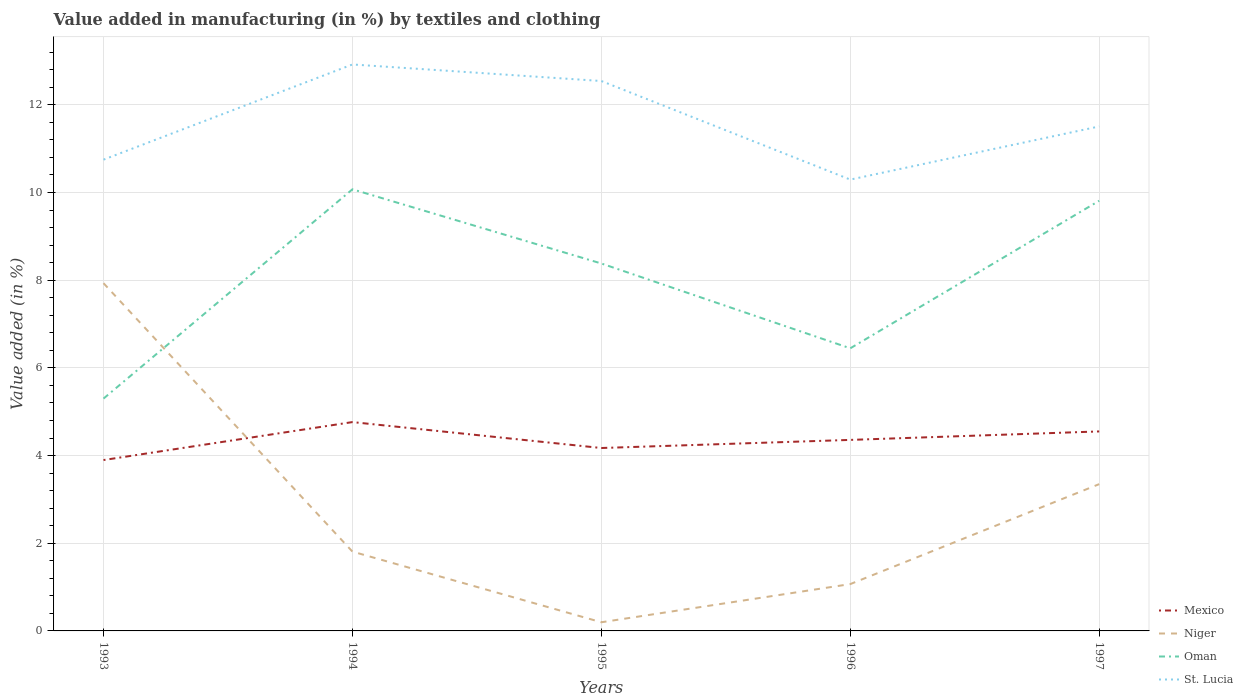Does the line corresponding to Oman intersect with the line corresponding to St. Lucia?
Offer a very short reply. No. Is the number of lines equal to the number of legend labels?
Provide a succinct answer. Yes. Across all years, what is the maximum percentage of value added in manufacturing by textiles and clothing in Mexico?
Provide a short and direct response. 3.9. What is the total percentage of value added in manufacturing by textiles and clothing in Oman in the graph?
Give a very brief answer. 0.26. What is the difference between the highest and the second highest percentage of value added in manufacturing by textiles and clothing in Niger?
Your answer should be very brief. 7.73. What is the difference between the highest and the lowest percentage of value added in manufacturing by textiles and clothing in Mexico?
Give a very brief answer. 3. How many lines are there?
Offer a very short reply. 4. What is the difference between two consecutive major ticks on the Y-axis?
Provide a succinct answer. 2. Does the graph contain grids?
Your response must be concise. Yes. How many legend labels are there?
Your response must be concise. 4. How are the legend labels stacked?
Your answer should be very brief. Vertical. What is the title of the graph?
Give a very brief answer. Value added in manufacturing (in %) by textiles and clothing. Does "Mali" appear as one of the legend labels in the graph?
Make the answer very short. No. What is the label or title of the Y-axis?
Ensure brevity in your answer.  Value added (in %). What is the Value added (in %) in Mexico in 1993?
Offer a very short reply. 3.9. What is the Value added (in %) of Niger in 1993?
Offer a very short reply. 7.93. What is the Value added (in %) of Oman in 1993?
Your answer should be compact. 5.3. What is the Value added (in %) in St. Lucia in 1993?
Give a very brief answer. 10.75. What is the Value added (in %) in Mexico in 1994?
Your answer should be compact. 4.76. What is the Value added (in %) in Niger in 1994?
Offer a very short reply. 1.81. What is the Value added (in %) in Oman in 1994?
Provide a succinct answer. 10.07. What is the Value added (in %) of St. Lucia in 1994?
Offer a terse response. 12.92. What is the Value added (in %) of Mexico in 1995?
Your answer should be very brief. 4.17. What is the Value added (in %) of Niger in 1995?
Keep it short and to the point. 0.2. What is the Value added (in %) in Oman in 1995?
Ensure brevity in your answer.  8.38. What is the Value added (in %) in St. Lucia in 1995?
Provide a succinct answer. 12.54. What is the Value added (in %) in Mexico in 1996?
Give a very brief answer. 4.36. What is the Value added (in %) of Niger in 1996?
Offer a terse response. 1.07. What is the Value added (in %) in Oman in 1996?
Your response must be concise. 6.45. What is the Value added (in %) of St. Lucia in 1996?
Provide a succinct answer. 10.29. What is the Value added (in %) of Mexico in 1997?
Your answer should be very brief. 4.55. What is the Value added (in %) in Niger in 1997?
Ensure brevity in your answer.  3.35. What is the Value added (in %) of Oman in 1997?
Offer a terse response. 9.81. What is the Value added (in %) of St. Lucia in 1997?
Your response must be concise. 11.51. Across all years, what is the maximum Value added (in %) of Mexico?
Offer a terse response. 4.76. Across all years, what is the maximum Value added (in %) in Niger?
Keep it short and to the point. 7.93. Across all years, what is the maximum Value added (in %) in Oman?
Offer a very short reply. 10.07. Across all years, what is the maximum Value added (in %) of St. Lucia?
Give a very brief answer. 12.92. Across all years, what is the minimum Value added (in %) of Mexico?
Give a very brief answer. 3.9. Across all years, what is the minimum Value added (in %) in Niger?
Offer a very short reply. 0.2. Across all years, what is the minimum Value added (in %) of Oman?
Ensure brevity in your answer.  5.3. Across all years, what is the minimum Value added (in %) in St. Lucia?
Offer a terse response. 10.29. What is the total Value added (in %) of Mexico in the graph?
Your answer should be compact. 21.74. What is the total Value added (in %) of Niger in the graph?
Your response must be concise. 14.35. What is the total Value added (in %) in Oman in the graph?
Provide a short and direct response. 40.01. What is the total Value added (in %) of St. Lucia in the graph?
Keep it short and to the point. 58.01. What is the difference between the Value added (in %) in Mexico in 1993 and that in 1994?
Offer a very short reply. -0.87. What is the difference between the Value added (in %) in Niger in 1993 and that in 1994?
Your answer should be compact. 6.12. What is the difference between the Value added (in %) in Oman in 1993 and that in 1994?
Offer a terse response. -4.77. What is the difference between the Value added (in %) in St. Lucia in 1993 and that in 1994?
Offer a terse response. -2.17. What is the difference between the Value added (in %) of Mexico in 1993 and that in 1995?
Offer a very short reply. -0.27. What is the difference between the Value added (in %) of Niger in 1993 and that in 1995?
Give a very brief answer. 7.73. What is the difference between the Value added (in %) in Oman in 1993 and that in 1995?
Give a very brief answer. -3.08. What is the difference between the Value added (in %) in St. Lucia in 1993 and that in 1995?
Offer a terse response. -1.79. What is the difference between the Value added (in %) in Mexico in 1993 and that in 1996?
Your answer should be compact. -0.46. What is the difference between the Value added (in %) of Niger in 1993 and that in 1996?
Offer a very short reply. 6.86. What is the difference between the Value added (in %) of Oman in 1993 and that in 1996?
Your answer should be compact. -1.15. What is the difference between the Value added (in %) in St. Lucia in 1993 and that in 1996?
Your response must be concise. 0.45. What is the difference between the Value added (in %) of Mexico in 1993 and that in 1997?
Ensure brevity in your answer.  -0.65. What is the difference between the Value added (in %) of Niger in 1993 and that in 1997?
Make the answer very short. 4.58. What is the difference between the Value added (in %) in Oman in 1993 and that in 1997?
Offer a very short reply. -4.51. What is the difference between the Value added (in %) of St. Lucia in 1993 and that in 1997?
Your response must be concise. -0.76. What is the difference between the Value added (in %) in Mexico in 1994 and that in 1995?
Give a very brief answer. 0.59. What is the difference between the Value added (in %) in Niger in 1994 and that in 1995?
Provide a short and direct response. 1.61. What is the difference between the Value added (in %) in Oman in 1994 and that in 1995?
Ensure brevity in your answer.  1.69. What is the difference between the Value added (in %) in St. Lucia in 1994 and that in 1995?
Give a very brief answer. 0.38. What is the difference between the Value added (in %) in Mexico in 1994 and that in 1996?
Give a very brief answer. 0.41. What is the difference between the Value added (in %) in Niger in 1994 and that in 1996?
Offer a terse response. 0.74. What is the difference between the Value added (in %) in Oman in 1994 and that in 1996?
Your answer should be very brief. 3.63. What is the difference between the Value added (in %) in St. Lucia in 1994 and that in 1996?
Offer a terse response. 2.63. What is the difference between the Value added (in %) in Mexico in 1994 and that in 1997?
Your response must be concise. 0.21. What is the difference between the Value added (in %) in Niger in 1994 and that in 1997?
Offer a very short reply. -1.54. What is the difference between the Value added (in %) of Oman in 1994 and that in 1997?
Give a very brief answer. 0.26. What is the difference between the Value added (in %) in St. Lucia in 1994 and that in 1997?
Give a very brief answer. 1.41. What is the difference between the Value added (in %) in Mexico in 1995 and that in 1996?
Keep it short and to the point. -0.18. What is the difference between the Value added (in %) of Niger in 1995 and that in 1996?
Make the answer very short. -0.87. What is the difference between the Value added (in %) of Oman in 1995 and that in 1996?
Offer a very short reply. 1.93. What is the difference between the Value added (in %) of St. Lucia in 1995 and that in 1996?
Make the answer very short. 2.25. What is the difference between the Value added (in %) of Mexico in 1995 and that in 1997?
Give a very brief answer. -0.38. What is the difference between the Value added (in %) of Niger in 1995 and that in 1997?
Your response must be concise. -3.15. What is the difference between the Value added (in %) in Oman in 1995 and that in 1997?
Provide a short and direct response. -1.43. What is the difference between the Value added (in %) of St. Lucia in 1995 and that in 1997?
Provide a succinct answer. 1.04. What is the difference between the Value added (in %) of Mexico in 1996 and that in 1997?
Give a very brief answer. -0.19. What is the difference between the Value added (in %) in Niger in 1996 and that in 1997?
Provide a short and direct response. -2.28. What is the difference between the Value added (in %) of Oman in 1996 and that in 1997?
Offer a terse response. -3.37. What is the difference between the Value added (in %) in St. Lucia in 1996 and that in 1997?
Ensure brevity in your answer.  -1.21. What is the difference between the Value added (in %) in Mexico in 1993 and the Value added (in %) in Niger in 1994?
Offer a terse response. 2.09. What is the difference between the Value added (in %) of Mexico in 1993 and the Value added (in %) of Oman in 1994?
Your answer should be very brief. -6.18. What is the difference between the Value added (in %) in Mexico in 1993 and the Value added (in %) in St. Lucia in 1994?
Make the answer very short. -9.02. What is the difference between the Value added (in %) of Niger in 1993 and the Value added (in %) of Oman in 1994?
Ensure brevity in your answer.  -2.14. What is the difference between the Value added (in %) in Niger in 1993 and the Value added (in %) in St. Lucia in 1994?
Provide a short and direct response. -4.99. What is the difference between the Value added (in %) in Oman in 1993 and the Value added (in %) in St. Lucia in 1994?
Ensure brevity in your answer.  -7.62. What is the difference between the Value added (in %) in Mexico in 1993 and the Value added (in %) in Niger in 1995?
Give a very brief answer. 3.7. What is the difference between the Value added (in %) in Mexico in 1993 and the Value added (in %) in Oman in 1995?
Make the answer very short. -4.48. What is the difference between the Value added (in %) of Mexico in 1993 and the Value added (in %) of St. Lucia in 1995?
Keep it short and to the point. -8.64. What is the difference between the Value added (in %) of Niger in 1993 and the Value added (in %) of Oman in 1995?
Offer a very short reply. -0.45. What is the difference between the Value added (in %) of Niger in 1993 and the Value added (in %) of St. Lucia in 1995?
Make the answer very short. -4.61. What is the difference between the Value added (in %) in Oman in 1993 and the Value added (in %) in St. Lucia in 1995?
Ensure brevity in your answer.  -7.24. What is the difference between the Value added (in %) of Mexico in 1993 and the Value added (in %) of Niger in 1996?
Make the answer very short. 2.83. What is the difference between the Value added (in %) of Mexico in 1993 and the Value added (in %) of Oman in 1996?
Make the answer very short. -2.55. What is the difference between the Value added (in %) of Mexico in 1993 and the Value added (in %) of St. Lucia in 1996?
Provide a succinct answer. -6.4. What is the difference between the Value added (in %) of Niger in 1993 and the Value added (in %) of Oman in 1996?
Keep it short and to the point. 1.49. What is the difference between the Value added (in %) in Niger in 1993 and the Value added (in %) in St. Lucia in 1996?
Make the answer very short. -2.36. What is the difference between the Value added (in %) in Oman in 1993 and the Value added (in %) in St. Lucia in 1996?
Ensure brevity in your answer.  -5. What is the difference between the Value added (in %) of Mexico in 1993 and the Value added (in %) of Niger in 1997?
Your response must be concise. 0.55. What is the difference between the Value added (in %) of Mexico in 1993 and the Value added (in %) of Oman in 1997?
Give a very brief answer. -5.91. What is the difference between the Value added (in %) in Mexico in 1993 and the Value added (in %) in St. Lucia in 1997?
Your response must be concise. -7.61. What is the difference between the Value added (in %) of Niger in 1993 and the Value added (in %) of Oman in 1997?
Offer a terse response. -1.88. What is the difference between the Value added (in %) in Niger in 1993 and the Value added (in %) in St. Lucia in 1997?
Ensure brevity in your answer.  -3.58. What is the difference between the Value added (in %) in Oman in 1993 and the Value added (in %) in St. Lucia in 1997?
Give a very brief answer. -6.21. What is the difference between the Value added (in %) in Mexico in 1994 and the Value added (in %) in Niger in 1995?
Provide a succinct answer. 4.57. What is the difference between the Value added (in %) in Mexico in 1994 and the Value added (in %) in Oman in 1995?
Keep it short and to the point. -3.62. What is the difference between the Value added (in %) of Mexico in 1994 and the Value added (in %) of St. Lucia in 1995?
Give a very brief answer. -7.78. What is the difference between the Value added (in %) in Niger in 1994 and the Value added (in %) in Oman in 1995?
Provide a succinct answer. -6.57. What is the difference between the Value added (in %) in Niger in 1994 and the Value added (in %) in St. Lucia in 1995?
Provide a short and direct response. -10.73. What is the difference between the Value added (in %) of Oman in 1994 and the Value added (in %) of St. Lucia in 1995?
Your response must be concise. -2.47. What is the difference between the Value added (in %) of Mexico in 1994 and the Value added (in %) of Niger in 1996?
Provide a short and direct response. 3.69. What is the difference between the Value added (in %) of Mexico in 1994 and the Value added (in %) of Oman in 1996?
Your response must be concise. -1.68. What is the difference between the Value added (in %) of Mexico in 1994 and the Value added (in %) of St. Lucia in 1996?
Keep it short and to the point. -5.53. What is the difference between the Value added (in %) of Niger in 1994 and the Value added (in %) of Oman in 1996?
Provide a succinct answer. -4.64. What is the difference between the Value added (in %) in Niger in 1994 and the Value added (in %) in St. Lucia in 1996?
Your answer should be compact. -8.48. What is the difference between the Value added (in %) of Oman in 1994 and the Value added (in %) of St. Lucia in 1996?
Offer a very short reply. -0.22. What is the difference between the Value added (in %) of Mexico in 1994 and the Value added (in %) of Niger in 1997?
Provide a succinct answer. 1.42. What is the difference between the Value added (in %) of Mexico in 1994 and the Value added (in %) of Oman in 1997?
Ensure brevity in your answer.  -5.05. What is the difference between the Value added (in %) in Mexico in 1994 and the Value added (in %) in St. Lucia in 1997?
Your answer should be very brief. -6.74. What is the difference between the Value added (in %) in Niger in 1994 and the Value added (in %) in Oman in 1997?
Offer a very short reply. -8. What is the difference between the Value added (in %) of Niger in 1994 and the Value added (in %) of St. Lucia in 1997?
Make the answer very short. -9.7. What is the difference between the Value added (in %) in Oman in 1994 and the Value added (in %) in St. Lucia in 1997?
Ensure brevity in your answer.  -1.43. What is the difference between the Value added (in %) of Mexico in 1995 and the Value added (in %) of Niger in 1996?
Provide a short and direct response. 3.1. What is the difference between the Value added (in %) of Mexico in 1995 and the Value added (in %) of Oman in 1996?
Give a very brief answer. -2.27. What is the difference between the Value added (in %) of Mexico in 1995 and the Value added (in %) of St. Lucia in 1996?
Offer a terse response. -6.12. What is the difference between the Value added (in %) of Niger in 1995 and the Value added (in %) of Oman in 1996?
Your answer should be compact. -6.25. What is the difference between the Value added (in %) in Niger in 1995 and the Value added (in %) in St. Lucia in 1996?
Offer a terse response. -10.1. What is the difference between the Value added (in %) of Oman in 1995 and the Value added (in %) of St. Lucia in 1996?
Make the answer very short. -1.91. What is the difference between the Value added (in %) in Mexico in 1995 and the Value added (in %) in Niger in 1997?
Offer a very short reply. 0.82. What is the difference between the Value added (in %) in Mexico in 1995 and the Value added (in %) in Oman in 1997?
Your answer should be very brief. -5.64. What is the difference between the Value added (in %) of Mexico in 1995 and the Value added (in %) of St. Lucia in 1997?
Offer a terse response. -7.33. What is the difference between the Value added (in %) of Niger in 1995 and the Value added (in %) of Oman in 1997?
Provide a succinct answer. -9.61. What is the difference between the Value added (in %) of Niger in 1995 and the Value added (in %) of St. Lucia in 1997?
Your response must be concise. -11.31. What is the difference between the Value added (in %) in Oman in 1995 and the Value added (in %) in St. Lucia in 1997?
Provide a succinct answer. -3.13. What is the difference between the Value added (in %) in Mexico in 1996 and the Value added (in %) in Niger in 1997?
Offer a very short reply. 1.01. What is the difference between the Value added (in %) of Mexico in 1996 and the Value added (in %) of Oman in 1997?
Make the answer very short. -5.45. What is the difference between the Value added (in %) of Mexico in 1996 and the Value added (in %) of St. Lucia in 1997?
Your answer should be compact. -7.15. What is the difference between the Value added (in %) of Niger in 1996 and the Value added (in %) of Oman in 1997?
Provide a short and direct response. -8.74. What is the difference between the Value added (in %) in Niger in 1996 and the Value added (in %) in St. Lucia in 1997?
Your answer should be very brief. -10.44. What is the difference between the Value added (in %) of Oman in 1996 and the Value added (in %) of St. Lucia in 1997?
Keep it short and to the point. -5.06. What is the average Value added (in %) in Mexico per year?
Give a very brief answer. 4.35. What is the average Value added (in %) of Niger per year?
Make the answer very short. 2.87. What is the average Value added (in %) in Oman per year?
Make the answer very short. 8. What is the average Value added (in %) in St. Lucia per year?
Give a very brief answer. 11.6. In the year 1993, what is the difference between the Value added (in %) in Mexico and Value added (in %) in Niger?
Your answer should be very brief. -4.03. In the year 1993, what is the difference between the Value added (in %) in Mexico and Value added (in %) in Oman?
Your answer should be compact. -1.4. In the year 1993, what is the difference between the Value added (in %) of Mexico and Value added (in %) of St. Lucia?
Your response must be concise. -6.85. In the year 1993, what is the difference between the Value added (in %) in Niger and Value added (in %) in Oman?
Offer a very short reply. 2.63. In the year 1993, what is the difference between the Value added (in %) of Niger and Value added (in %) of St. Lucia?
Offer a very short reply. -2.82. In the year 1993, what is the difference between the Value added (in %) of Oman and Value added (in %) of St. Lucia?
Keep it short and to the point. -5.45. In the year 1994, what is the difference between the Value added (in %) in Mexico and Value added (in %) in Niger?
Offer a very short reply. 2.95. In the year 1994, what is the difference between the Value added (in %) of Mexico and Value added (in %) of Oman?
Offer a very short reply. -5.31. In the year 1994, what is the difference between the Value added (in %) of Mexico and Value added (in %) of St. Lucia?
Give a very brief answer. -8.16. In the year 1994, what is the difference between the Value added (in %) of Niger and Value added (in %) of Oman?
Ensure brevity in your answer.  -8.26. In the year 1994, what is the difference between the Value added (in %) in Niger and Value added (in %) in St. Lucia?
Provide a short and direct response. -11.11. In the year 1994, what is the difference between the Value added (in %) in Oman and Value added (in %) in St. Lucia?
Provide a short and direct response. -2.85. In the year 1995, what is the difference between the Value added (in %) in Mexico and Value added (in %) in Niger?
Provide a succinct answer. 3.97. In the year 1995, what is the difference between the Value added (in %) in Mexico and Value added (in %) in Oman?
Provide a succinct answer. -4.21. In the year 1995, what is the difference between the Value added (in %) of Mexico and Value added (in %) of St. Lucia?
Ensure brevity in your answer.  -8.37. In the year 1995, what is the difference between the Value added (in %) of Niger and Value added (in %) of Oman?
Your answer should be compact. -8.18. In the year 1995, what is the difference between the Value added (in %) of Niger and Value added (in %) of St. Lucia?
Provide a succinct answer. -12.34. In the year 1995, what is the difference between the Value added (in %) in Oman and Value added (in %) in St. Lucia?
Offer a terse response. -4.16. In the year 1996, what is the difference between the Value added (in %) of Mexico and Value added (in %) of Niger?
Make the answer very short. 3.29. In the year 1996, what is the difference between the Value added (in %) in Mexico and Value added (in %) in Oman?
Offer a very short reply. -2.09. In the year 1996, what is the difference between the Value added (in %) of Mexico and Value added (in %) of St. Lucia?
Keep it short and to the point. -5.94. In the year 1996, what is the difference between the Value added (in %) in Niger and Value added (in %) in Oman?
Give a very brief answer. -5.38. In the year 1996, what is the difference between the Value added (in %) of Niger and Value added (in %) of St. Lucia?
Provide a short and direct response. -9.23. In the year 1996, what is the difference between the Value added (in %) of Oman and Value added (in %) of St. Lucia?
Your response must be concise. -3.85. In the year 1997, what is the difference between the Value added (in %) in Mexico and Value added (in %) in Niger?
Make the answer very short. 1.2. In the year 1997, what is the difference between the Value added (in %) of Mexico and Value added (in %) of Oman?
Provide a succinct answer. -5.26. In the year 1997, what is the difference between the Value added (in %) of Mexico and Value added (in %) of St. Lucia?
Offer a very short reply. -6.96. In the year 1997, what is the difference between the Value added (in %) in Niger and Value added (in %) in Oman?
Offer a terse response. -6.46. In the year 1997, what is the difference between the Value added (in %) of Niger and Value added (in %) of St. Lucia?
Your response must be concise. -8.16. In the year 1997, what is the difference between the Value added (in %) in Oman and Value added (in %) in St. Lucia?
Give a very brief answer. -1.69. What is the ratio of the Value added (in %) of Mexico in 1993 to that in 1994?
Ensure brevity in your answer.  0.82. What is the ratio of the Value added (in %) of Niger in 1993 to that in 1994?
Make the answer very short. 4.38. What is the ratio of the Value added (in %) of Oman in 1993 to that in 1994?
Offer a very short reply. 0.53. What is the ratio of the Value added (in %) in St. Lucia in 1993 to that in 1994?
Provide a succinct answer. 0.83. What is the ratio of the Value added (in %) of Mexico in 1993 to that in 1995?
Your response must be concise. 0.93. What is the ratio of the Value added (in %) in Niger in 1993 to that in 1995?
Ensure brevity in your answer.  40.12. What is the ratio of the Value added (in %) of Oman in 1993 to that in 1995?
Offer a terse response. 0.63. What is the ratio of the Value added (in %) of St. Lucia in 1993 to that in 1995?
Provide a short and direct response. 0.86. What is the ratio of the Value added (in %) of Mexico in 1993 to that in 1996?
Your response must be concise. 0.89. What is the ratio of the Value added (in %) in Niger in 1993 to that in 1996?
Ensure brevity in your answer.  7.43. What is the ratio of the Value added (in %) in Oman in 1993 to that in 1996?
Keep it short and to the point. 0.82. What is the ratio of the Value added (in %) of St. Lucia in 1993 to that in 1996?
Provide a short and direct response. 1.04. What is the ratio of the Value added (in %) of Mexico in 1993 to that in 1997?
Keep it short and to the point. 0.86. What is the ratio of the Value added (in %) of Niger in 1993 to that in 1997?
Keep it short and to the point. 2.37. What is the ratio of the Value added (in %) of Oman in 1993 to that in 1997?
Provide a short and direct response. 0.54. What is the ratio of the Value added (in %) of St. Lucia in 1993 to that in 1997?
Ensure brevity in your answer.  0.93. What is the ratio of the Value added (in %) of Mexico in 1994 to that in 1995?
Give a very brief answer. 1.14. What is the ratio of the Value added (in %) of Niger in 1994 to that in 1995?
Make the answer very short. 9.15. What is the ratio of the Value added (in %) in Oman in 1994 to that in 1995?
Make the answer very short. 1.2. What is the ratio of the Value added (in %) in St. Lucia in 1994 to that in 1995?
Ensure brevity in your answer.  1.03. What is the ratio of the Value added (in %) in Mexico in 1994 to that in 1996?
Provide a succinct answer. 1.09. What is the ratio of the Value added (in %) in Niger in 1994 to that in 1996?
Your answer should be compact. 1.69. What is the ratio of the Value added (in %) of Oman in 1994 to that in 1996?
Ensure brevity in your answer.  1.56. What is the ratio of the Value added (in %) in St. Lucia in 1994 to that in 1996?
Your answer should be very brief. 1.26. What is the ratio of the Value added (in %) in Mexico in 1994 to that in 1997?
Offer a terse response. 1.05. What is the ratio of the Value added (in %) of Niger in 1994 to that in 1997?
Ensure brevity in your answer.  0.54. What is the ratio of the Value added (in %) of Oman in 1994 to that in 1997?
Make the answer very short. 1.03. What is the ratio of the Value added (in %) of St. Lucia in 1994 to that in 1997?
Your answer should be compact. 1.12. What is the ratio of the Value added (in %) of Mexico in 1995 to that in 1996?
Give a very brief answer. 0.96. What is the ratio of the Value added (in %) in Niger in 1995 to that in 1996?
Your answer should be very brief. 0.19. What is the ratio of the Value added (in %) of Oman in 1995 to that in 1996?
Your answer should be compact. 1.3. What is the ratio of the Value added (in %) in St. Lucia in 1995 to that in 1996?
Ensure brevity in your answer.  1.22. What is the ratio of the Value added (in %) in Mexico in 1995 to that in 1997?
Ensure brevity in your answer.  0.92. What is the ratio of the Value added (in %) in Niger in 1995 to that in 1997?
Ensure brevity in your answer.  0.06. What is the ratio of the Value added (in %) of Oman in 1995 to that in 1997?
Make the answer very short. 0.85. What is the ratio of the Value added (in %) in St. Lucia in 1995 to that in 1997?
Offer a terse response. 1.09. What is the ratio of the Value added (in %) of Mexico in 1996 to that in 1997?
Provide a short and direct response. 0.96. What is the ratio of the Value added (in %) in Niger in 1996 to that in 1997?
Your answer should be compact. 0.32. What is the ratio of the Value added (in %) in Oman in 1996 to that in 1997?
Offer a terse response. 0.66. What is the ratio of the Value added (in %) of St. Lucia in 1996 to that in 1997?
Provide a short and direct response. 0.89. What is the difference between the highest and the second highest Value added (in %) in Mexico?
Offer a very short reply. 0.21. What is the difference between the highest and the second highest Value added (in %) in Niger?
Provide a short and direct response. 4.58. What is the difference between the highest and the second highest Value added (in %) in Oman?
Ensure brevity in your answer.  0.26. What is the difference between the highest and the second highest Value added (in %) in St. Lucia?
Your response must be concise. 0.38. What is the difference between the highest and the lowest Value added (in %) in Mexico?
Give a very brief answer. 0.87. What is the difference between the highest and the lowest Value added (in %) of Niger?
Your response must be concise. 7.73. What is the difference between the highest and the lowest Value added (in %) in Oman?
Ensure brevity in your answer.  4.77. What is the difference between the highest and the lowest Value added (in %) in St. Lucia?
Offer a very short reply. 2.63. 